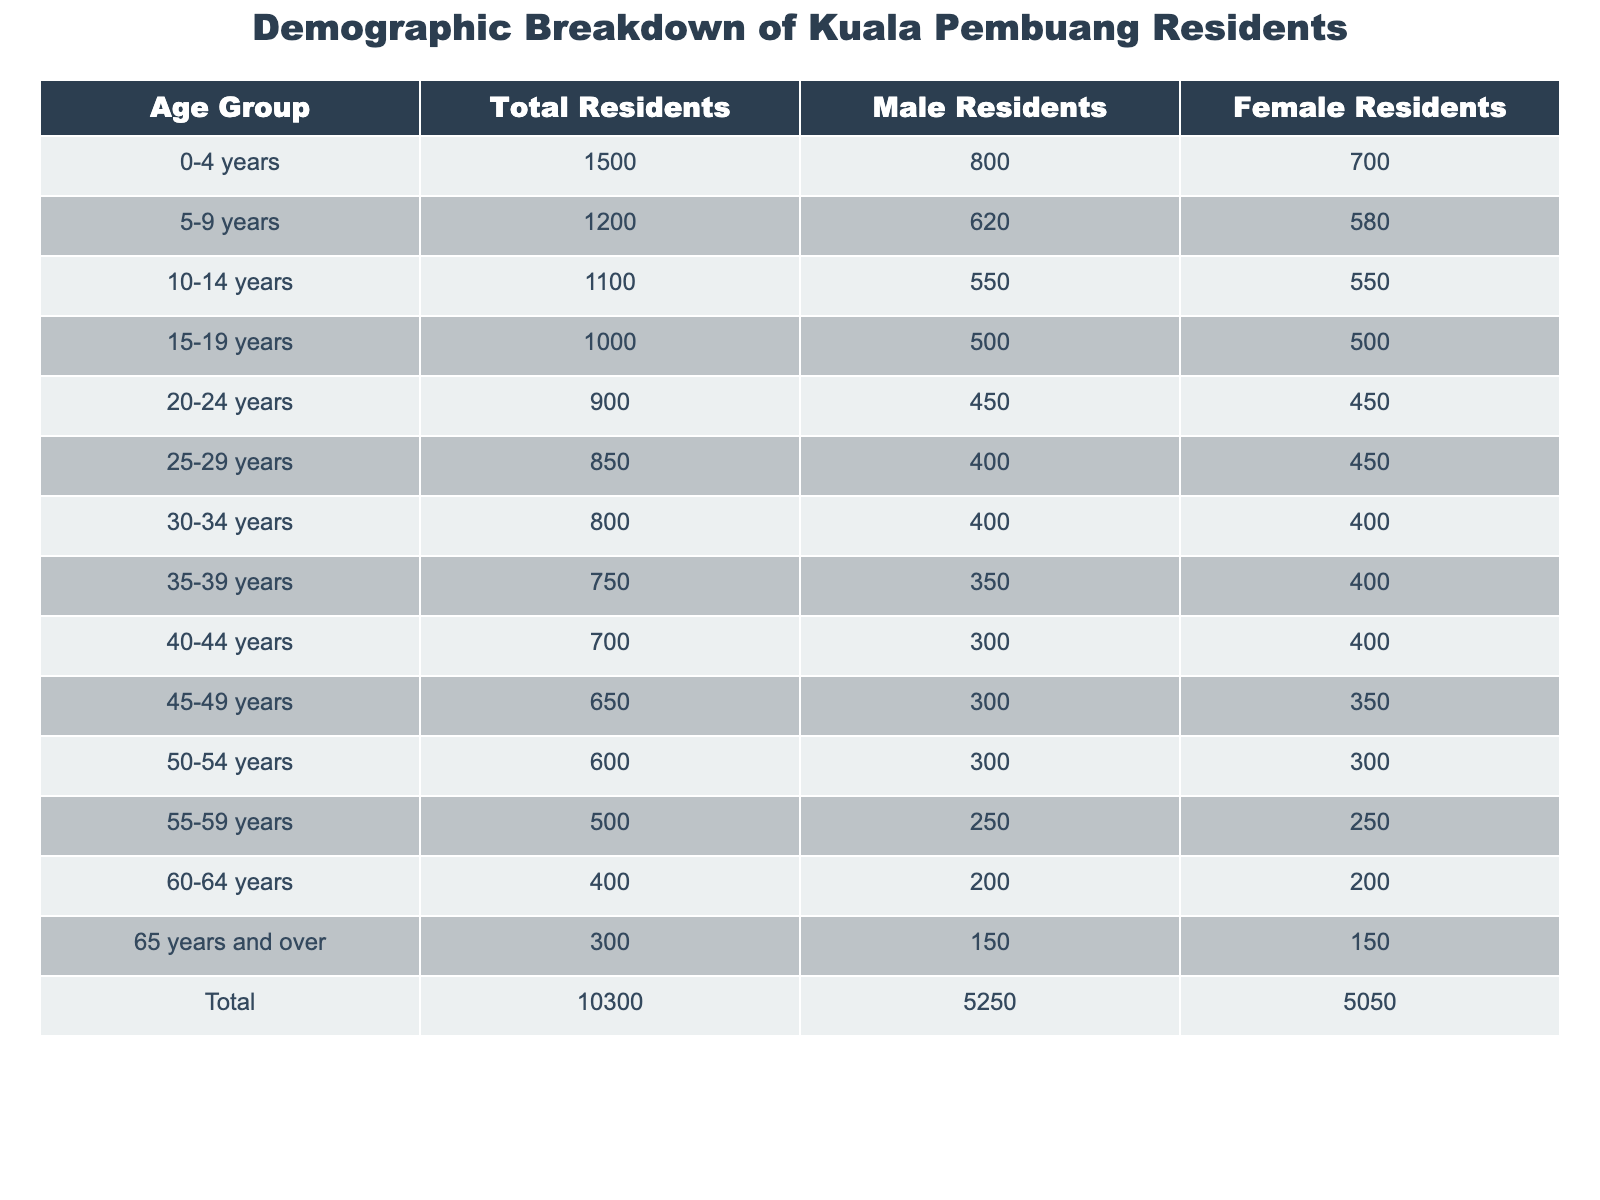What is the total number of residents in Kuala Pembuang? The total number of residents is directly stated in the table under "Total Residents," which is 10,300.
Answer: 10,300 How many male residents are there in the age group 25-29 years? Referring to the table, in the age group 25-29 years, the number of male residents is listed as 400.
Answer: 400 What is the total number of female residents across all age groups? The total number of female residents can be found by taking the value under "Total" in the Female Residents column, which is 5,050.
Answer: 5,050 Which age group has the highest number of male residents? The table shows that the age group 0-4 years has the highest number of male residents at 800.
Answer: 0-4 years How many more male residents are there compared to female residents in the 40-44 age group? For the 40-44 age group, there are 300 male residents and 400 female residents. The difference is 300 - 400, which equals -100; hence, there are 100 more female residents.
Answer: 100 What percentage of the total residents are aged 60 years and over? To find this percentage, identify the total number of residents aged 60 years and over (400) and divide it by the total number of residents (10,300), then multiply by 100. (400 / 10,300) * 100 is approximately 3.88%.
Answer: 3.88% Which age group has the same number of male and female residents? The age groups 10-14 years and 15-19 years both show 550 male and female residents.
Answer: 10-14 years and 15-19 years How many residents are there aged 30-39 years combined? Adding the residents in the age groups 30-34 years (800) and 35-39 years (750), we get 800 + 750 = 1,550.
Answer: 1,550 What is the male to female ratio for residents aged 50-54 years? The ratio can be calculated by taking the number of male residents (300) and dividing it by the number of female residents (300), giving us a ratio of 1:1.
Answer: 1:1 In which age group is the male population less than the female population? Examining the age groups, the 40-44 years, 45-49 years, 50-54 years, 55-59 years, and 60-64 years groups all show that there are fewer male residents than female residents.
Answer: 40-44 years, 45-49 years, 50-54 years, 55-59 years, 60-64 years What is the average number of residents per age group? To find the average, divide the total number of residents (10,300) by the number of age groups (7). Thus, 10,300 / 7 is approximately 1,471.43.
Answer: 1,471.43 